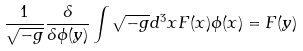Convert formula to latex. <formula><loc_0><loc_0><loc_500><loc_500>\frac { 1 } { \sqrt { - g } } \frac { \delta } { \delta \phi ( y ) } \int \sqrt { - g } d ^ { 3 } x F ( x ) \phi ( x ) = F ( y )</formula> 